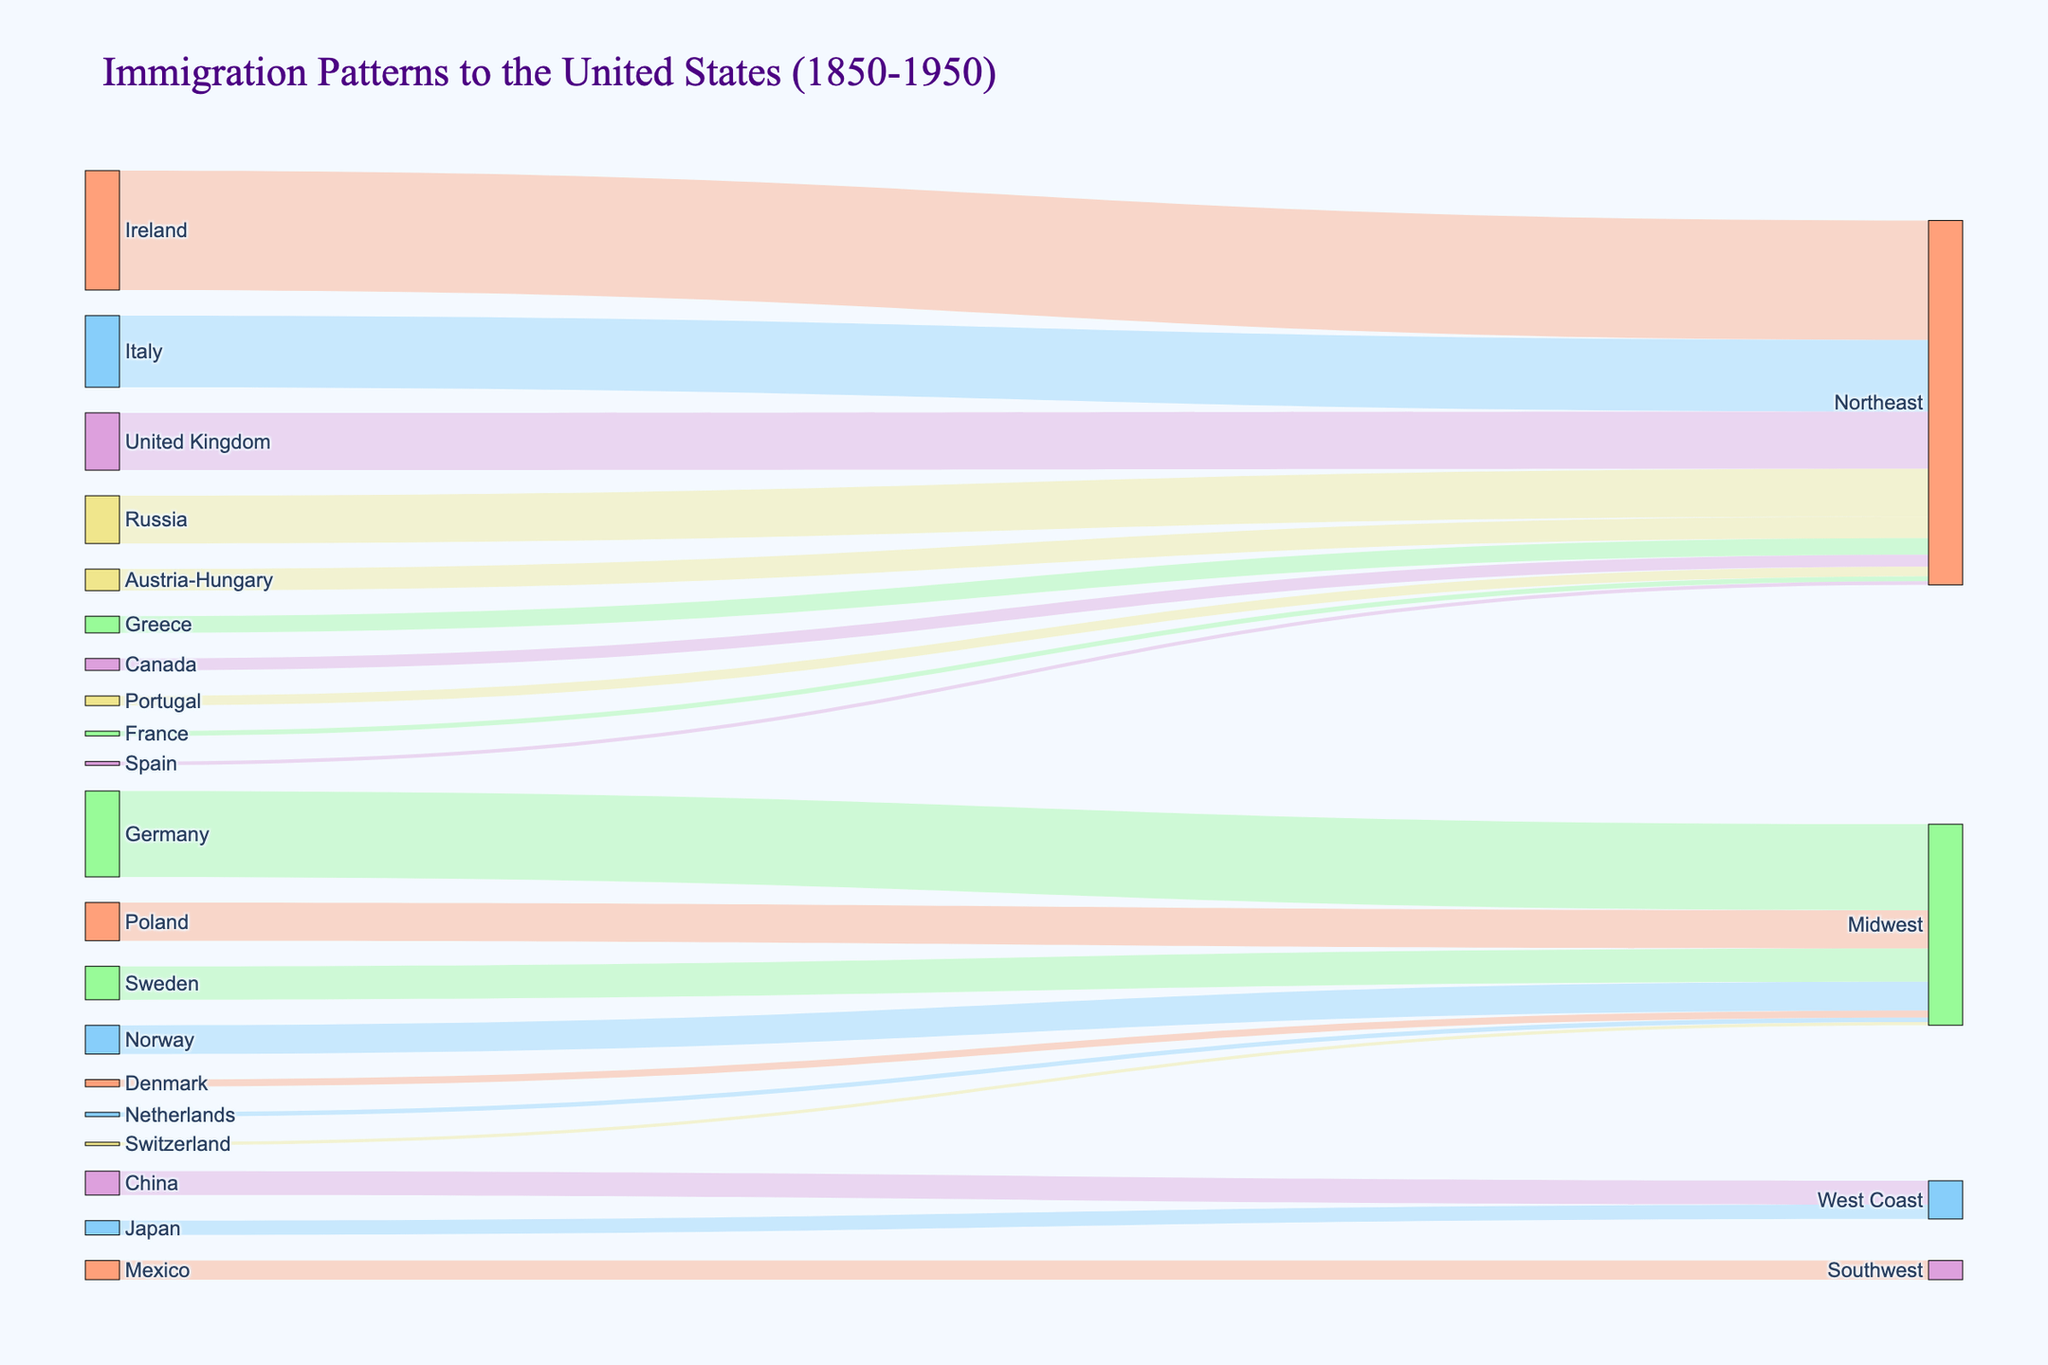What is the title of the Sankey Diagram? The title is typically displayed at the top of the diagram. In this case, it indicates the subject of the visualization.
Answer: Immigration Patterns to the United States (1850-1950) Which country had the largest number of immigrants to the Northeast region? By observing the largest flow into the Northeast region in the Sankey Diagram, one can identify the country with the most significant contribution.
Answer: Ireland How many regions are represented in the Sankey Diagram? Sankey Diagrams show flows from sources to targets. By counting the distinct target regions in the diagram, one can determine how many regions are shown.
Answer: 5 Which country had the least number of immigrants to the Northeast region? By examining the flows into the Northeast region, the thinnest flow represents the smallest number of immigrants.
Answer: Spain How does the number of immigrants from Germany to the Midwest compare to the number of immigrants from Poland to the Midwest? By comparing the thickness of the flows from Germany and Poland to the Midwest, one can determine which country had a larger number of immigrants.
Answer: Germany What is the total number of immigrants from Norway and Sweden to the Midwest combined? Summing the value of immigrants from both Norway and Sweden to the Midwest gives the total number. 600,000 (Norway) + 700,000 (Sweden) = 1,300,000
Answer: 1,300,000 How many more immigrants arrived from Italy to the Northeast than from Greece to the Northeast? Subtracting the number of immigrants from Greece from the number of immigrants from Italy provides the difference. 1,500,000 (Italy) - 350,000 (Greece) = 1,150,000
Answer: 1,150,000 Which country had the largest number of immigrants to the West Coast? By identifying the largest flow into the West Coast, one can determine the primary country of origin for the immigrants.
Answer: China In terms of immigrant numbers, how does the West Coast compare to the Southwest region? By summing the values of all flows into both regions and comparing them, you can see which region had more immigrants. For the West Coast: 500,000 (China) + 300,000 (Japan) = 800,000; For the Southwest: 400,000 (Mexico).
Answer: West Coast has more immigrants (800,000 vs 400,000) Which region received the fewest immigrants overall? By summing the number of immigrants to each region and comparing the totals, one can identify the region that received the least number of immigrants. For accurate calculation: Northeast: several values; Midwest: several values; West Coast: two values; Southwest: one value. Comparing these sums identifies the region with the smallest total.
Answer: Southwest 